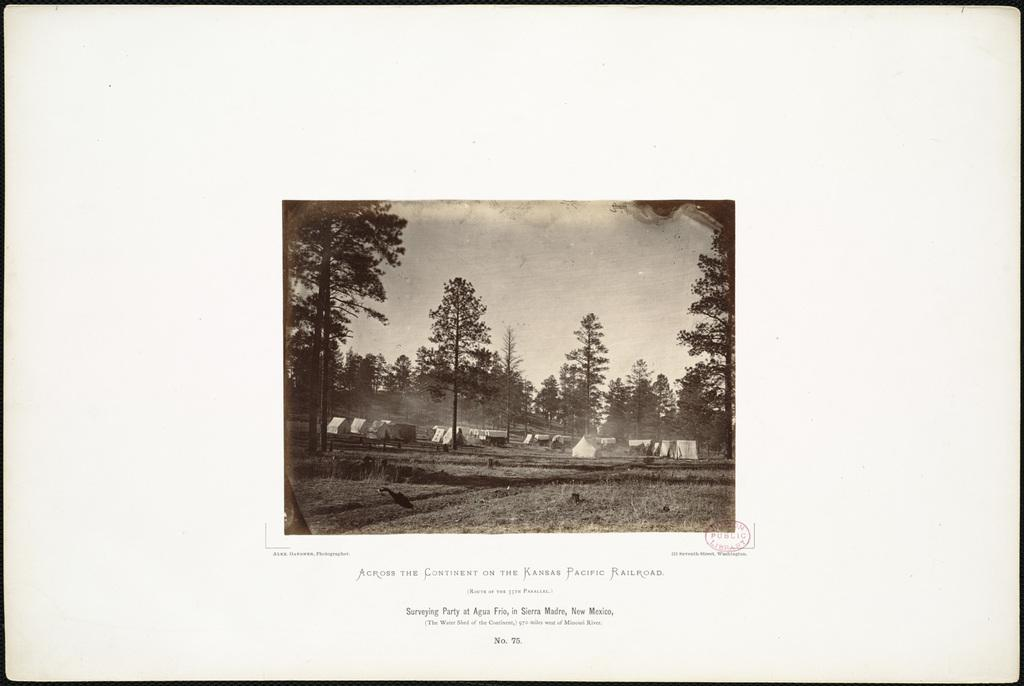What type of natural elements can be seen in the image? There are trees in the image. What part of the environment is visible in the image? The ground is visible in the image. What type of temporary shelters are present in the image? There are tents in the image. What part of the natural environment is visible in the image? The sky is visible in the image. What type of markings or symbols can be seen in the image? There are words written in the image. What type of official seal or mark is present in the image? There is a stamp in the image. What type of hook is used to hang the history book in the image? There is no hook or history book present in the image. 